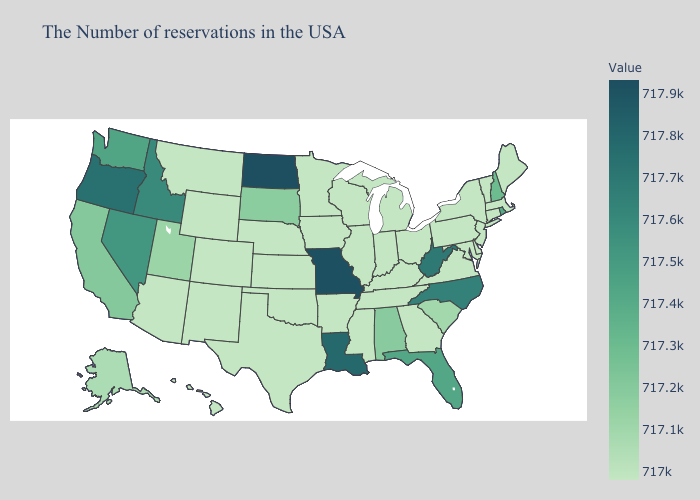Does North Dakota have the highest value in the USA?
Keep it brief. Yes. Does Rhode Island have a higher value than Utah?
Concise answer only. Yes. Which states hav the highest value in the West?
Answer briefly. Oregon. 